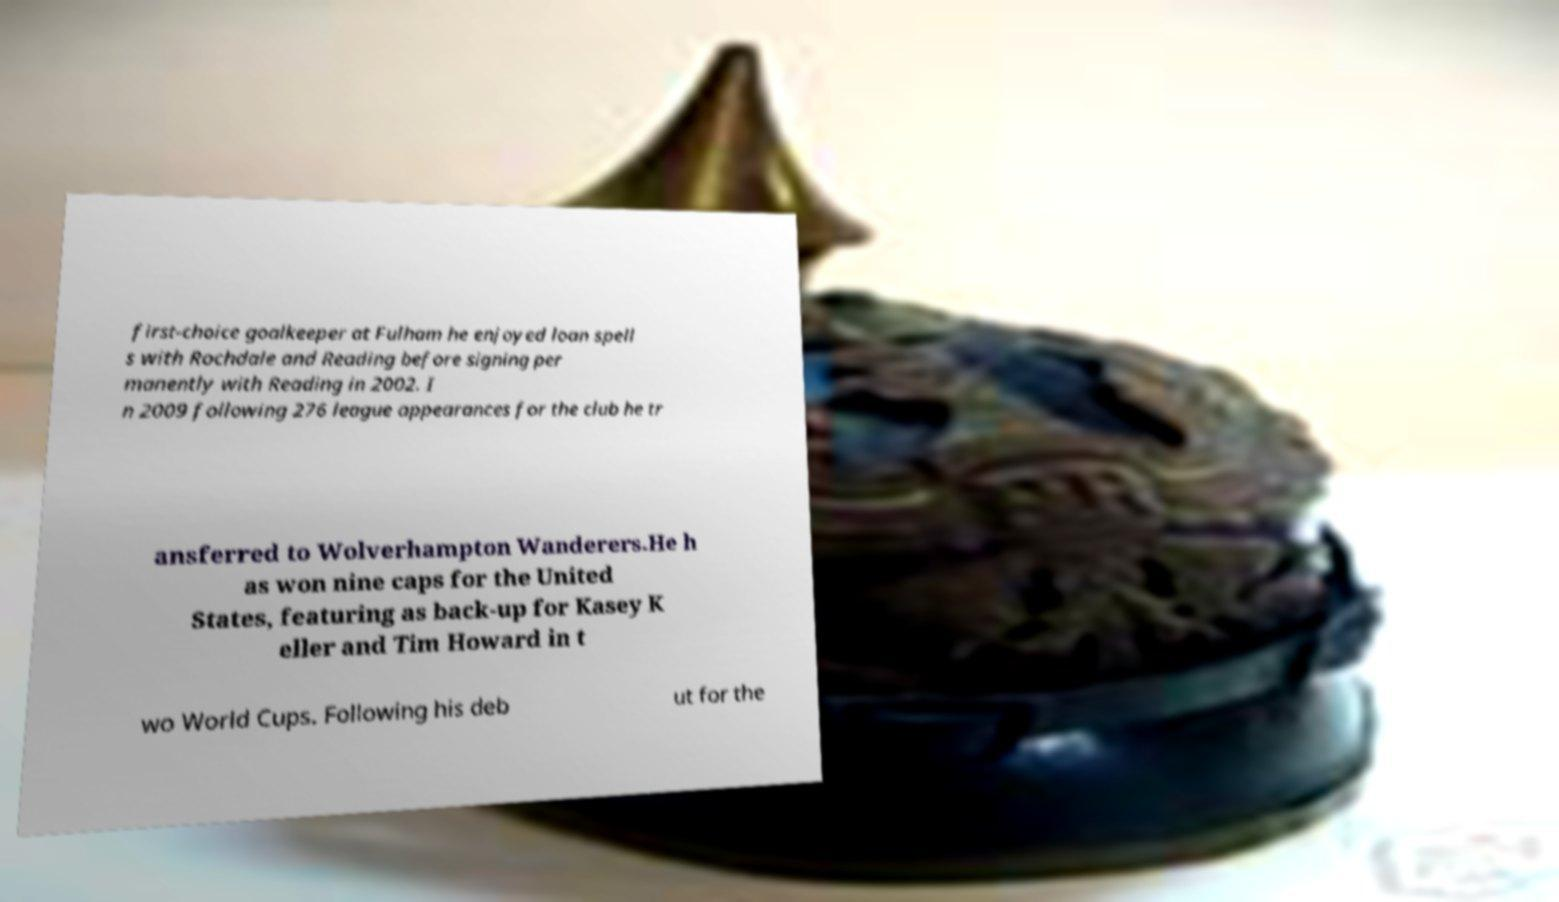Can you accurately transcribe the text from the provided image for me? first-choice goalkeeper at Fulham he enjoyed loan spell s with Rochdale and Reading before signing per manently with Reading in 2002. I n 2009 following 276 league appearances for the club he tr ansferred to Wolverhampton Wanderers.He h as won nine caps for the United States, featuring as back-up for Kasey K eller and Tim Howard in t wo World Cups. Following his deb ut for the 